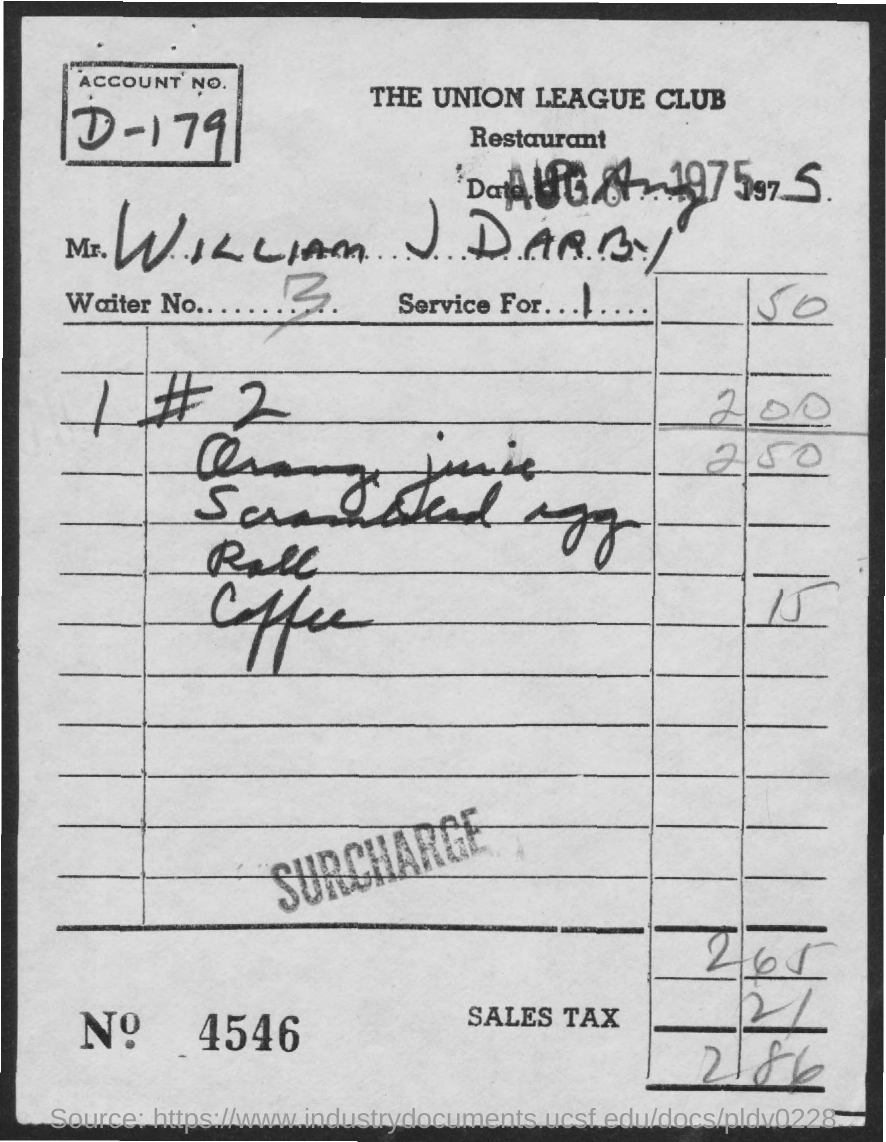What is name of the restaurant?
Keep it short and to the point. The union league club. What is the account no.?
Keep it short and to the point. D-179. What is the waiter no.?
Your answer should be compact. 3. What is the year mentioned in page?
Make the answer very short. 1975. What is the name of the customer?
Your answer should be compact. William J Darby. What is the bill no.?
Ensure brevity in your answer.  4546. What is the sales tax charged?
Make the answer very short. 21. What is the total amount?
Provide a succinct answer. 286. To how many is the service for?
Your answer should be compact. 1. 